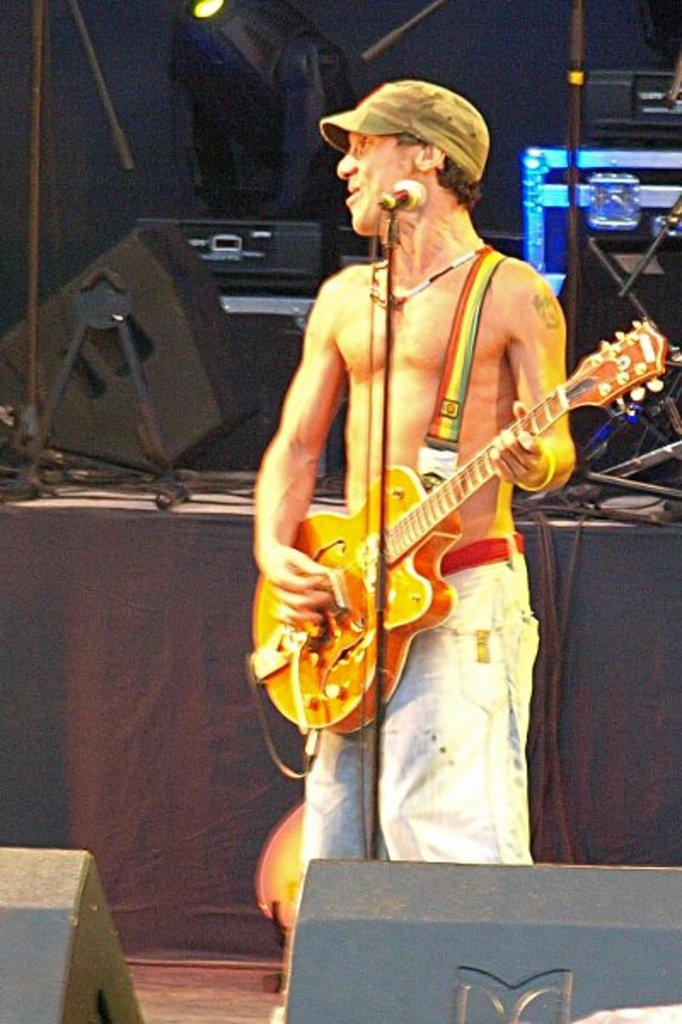What is the main subject of the image? There is a person in the image. What is the person doing in the image? The person is standing, playing a guitar, and singing with the help of a microphone. What type of achievement is the person celebrating in the image? The provided facts do not mention any specific achievement; the person is simply playing a guitar and singing with the help of a microphone. --- Facts: 1. There is a car in the image. 2. The car is red. 3. The car has four wheels. 4. The car has a license plate. 5. The car is parked on the street. Absurd Topics: parrot, dance, ocean Conversation: What is the main subject of the image? There is a car in the image. What color is the car? The car is red. How many wheels does the car have? The car has four wheels. Does the car have any identifying features? Yes, the car has a license plate. Where is the car located in the image? The car is parked on the street. Reasoning: Let's think step by step in order to produce the conversation. We start by identifying the main subject of the image, which is the car. Then, we describe the color, number of wheels, and the presence of a license plate. Finally, we mention the location of the car, which is parked on the street. Each question is designed to elicit a specific detail about the image that is known from the provided facts. Absurd Question/Answer: Can you see a parrot sitting on the car in the image? No, there is no parrot present in the image. Is the car parked near the ocean in the image? The provided facts do not mention any ocean or body of water; the car is parked on the 